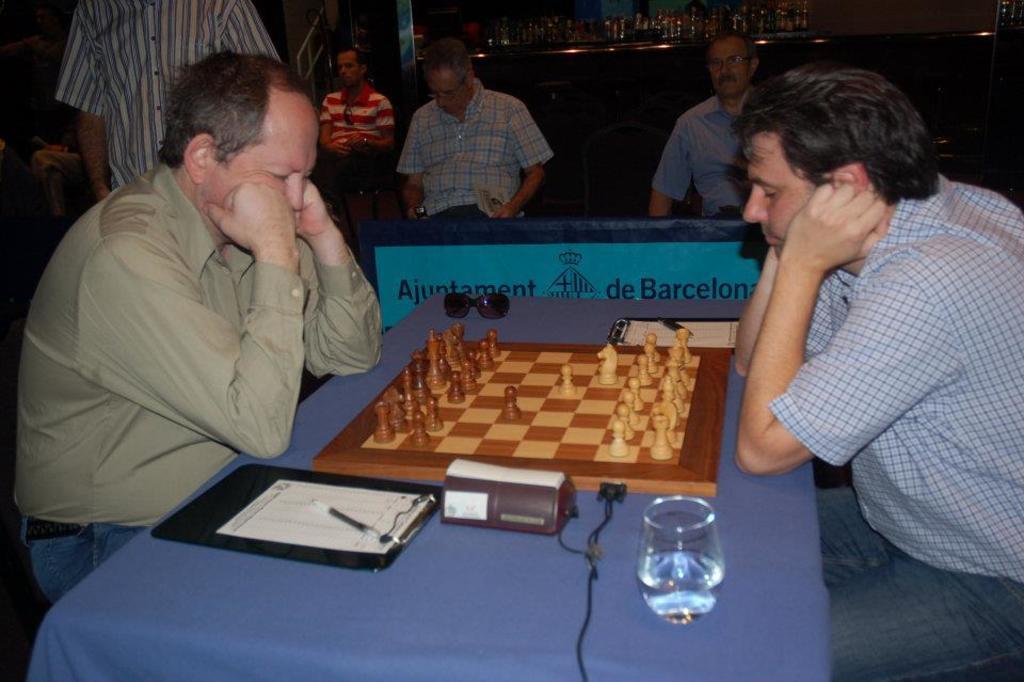How would you summarize this image in a sentence or two? Few persons are sitting on the chairs and this person standing. We can see glass,paper,pen,cable,chess board,glasses on the table. On the background we can see group of bottles on the table,wall. 